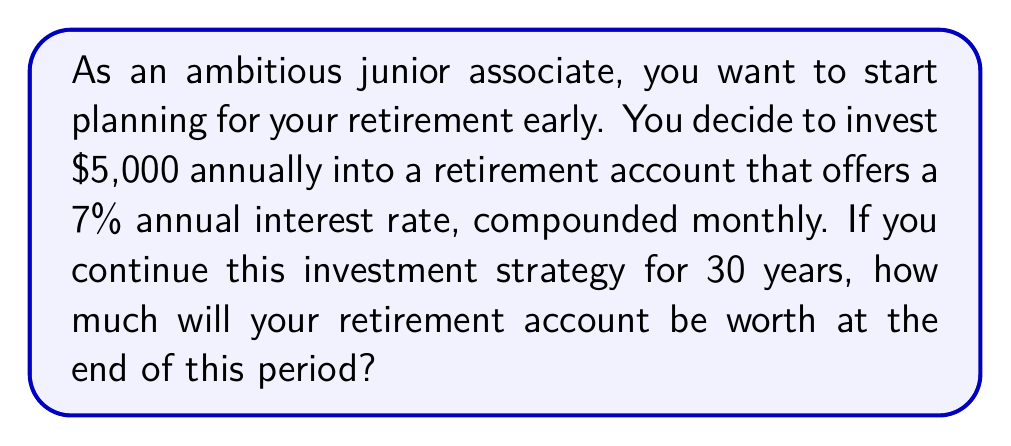Solve this math problem. To solve this problem, we'll use the compound interest formula for periodic investments:

$$A = P \cdot \frac{(1 + \frac{r}{n})^{nt} - 1}{\frac{r}{n}} \cdot (1 + \frac{r}{n})$$

Where:
$A$ = final amount
$P$ = periodic payment (annual investment)
$r$ = annual interest rate (as a decimal)
$n$ = number of times interest is compounded per year
$t$ = number of years

Given:
$P = \$5,000$
$r = 0.07$ (7% annual interest rate)
$n = 12$ (compounded monthly)
$t = 30$ years

Step 1: Substitute the values into the formula:

$$A = 5000 \cdot \frac{(1 + \frac{0.07}{12})^{12 \cdot 30} - 1}{\frac{0.07}{12}} \cdot (1 + \frac{0.07}{12})$$

Step 2: Simplify the expression inside the parentheses:

$$A = 5000 \cdot \frac{(1 + 0.005833)^{360} - 1}{0.005833} \cdot (1 + 0.005833)$$

Step 3: Calculate the exponent:

$$A = 5000 \cdot \frac{8.1136 - 1}{0.005833} \cdot 1.005833$$

Step 4: Perform the division:

$$A = 5000 \cdot 1221.96 \cdot 1.005833$$

Step 5: Multiply all terms:

$$A = 6,140,154.67$$

Therefore, after 30 years of investing $5,000 annually with a 7% interest rate compounded monthly, your retirement account will be worth approximately $6,140,154.67.
Answer: $6,140,154.67 